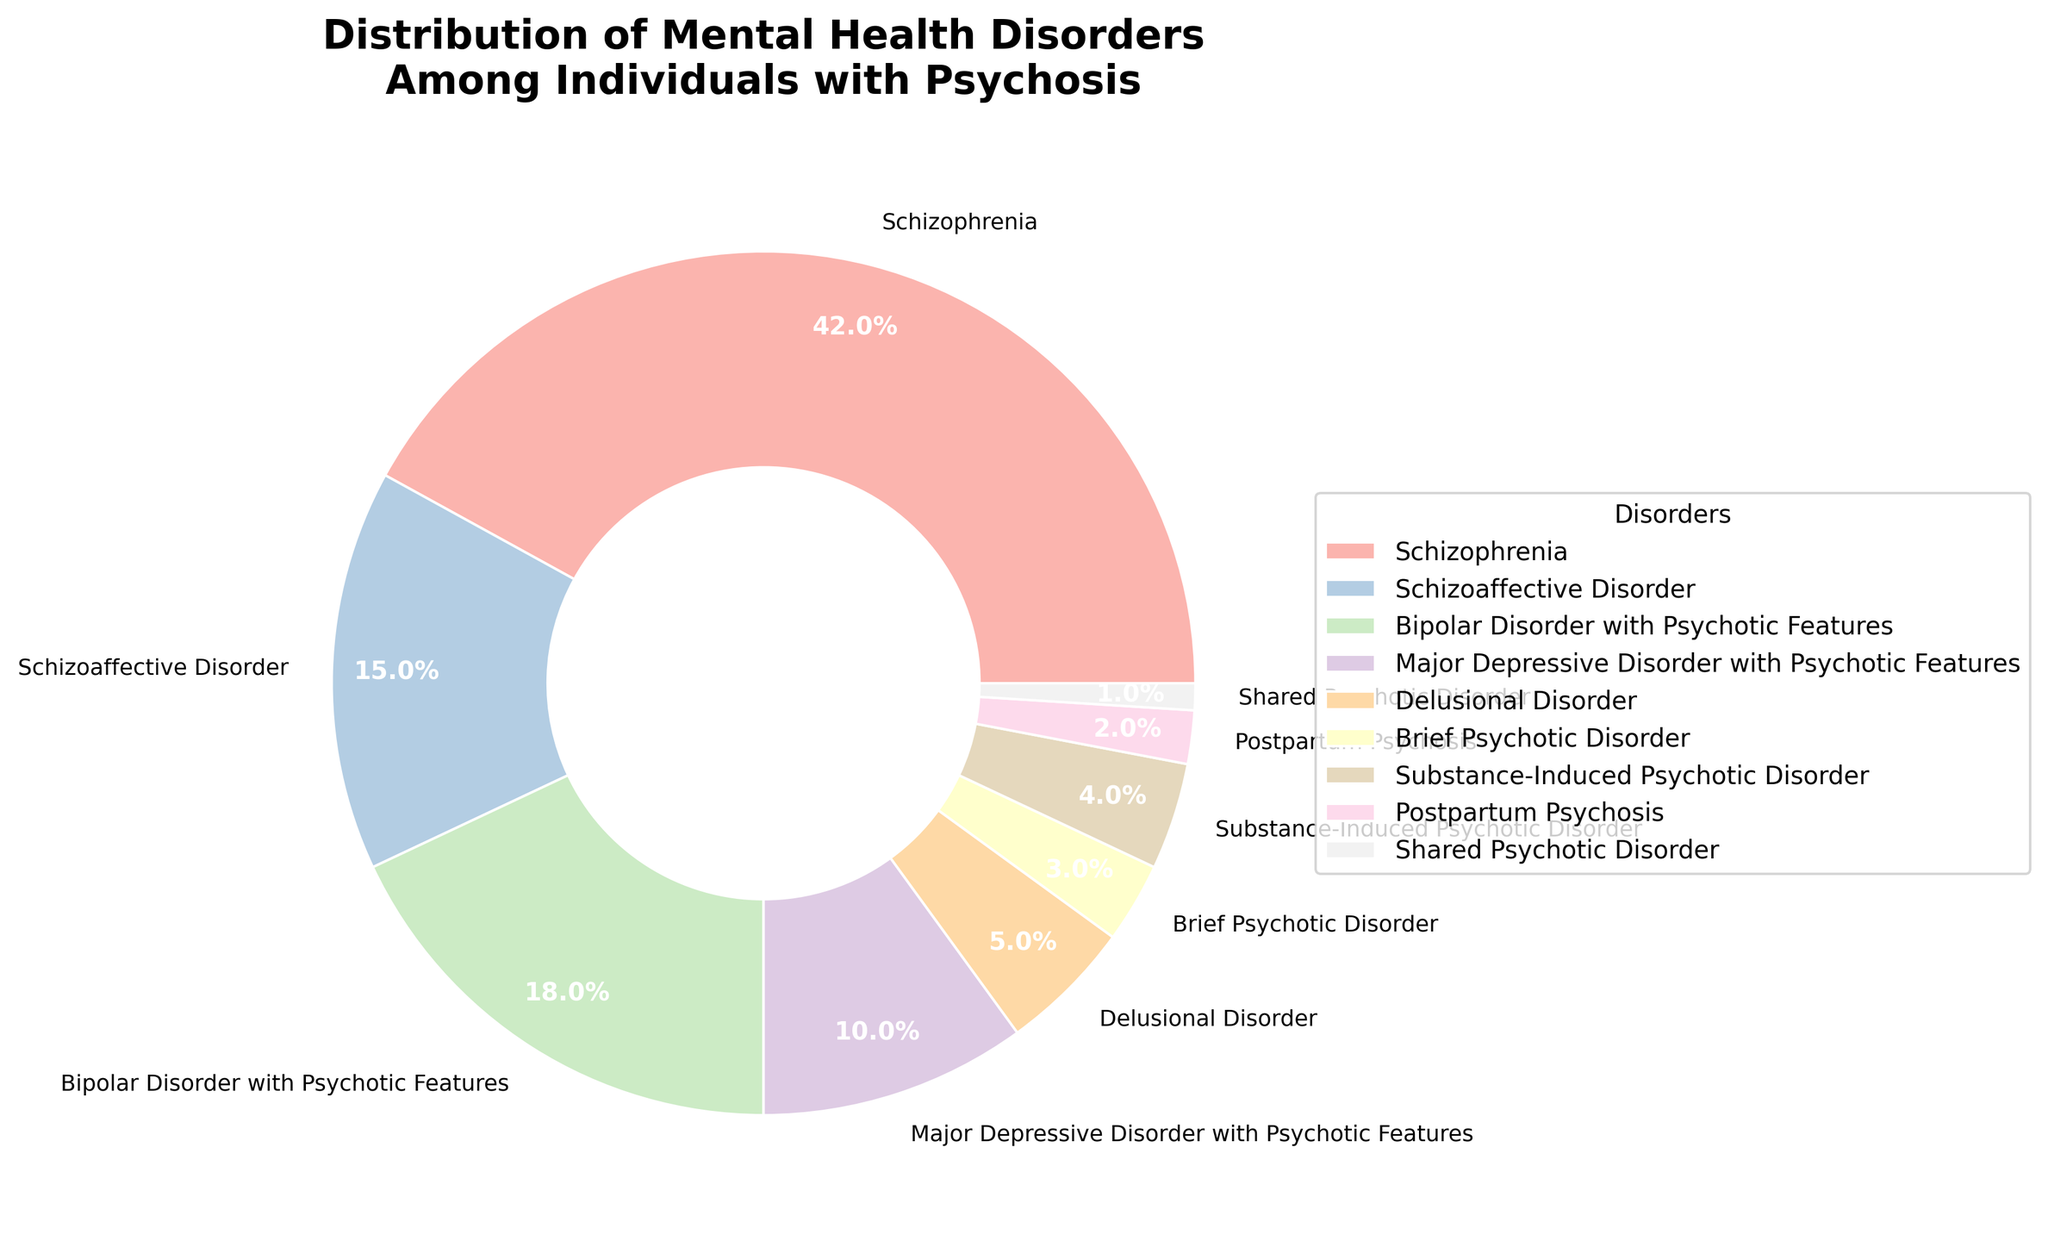What is the most common mental health disorder among individuals with psychosis as shown in the pie chart? The pie chart shows the distribution of different mental health disorders among individuals with psychosis. The largest section of the pie chart corresponds to Schizophrenia.
Answer: Schizophrenia What is the combined percentage of individuals with Schizoaffective Disorder and Major Depressive Disorder with Psychotic Features? The pie chart shows that Schizoaffective Disorder accounts for 15% and Major Depressive Disorder with Psychotic Features accounts for 10%. Adding these percentages together gives 15% + 10% = 25%.
Answer: 25% Which disorder has a higher percentage, Bipolar Disorder with Psychotic Features or Delusional Disorder? According to the pie chart, Bipolar Disorder with Psychotic Features has a percentage of 18%, while Delusional Disorder has a percentage of 5%. Since 18% is greater than 5%, Bipolar Disorder with Psychotic Features has a higher percentage.
Answer: Bipolar Disorder with Psychotic Features Which two disorders have the smallest representation in this population, jointly totaling 3%? The pie chart indicates that Postpartum Psychosis accounts for 2% and Shared Psychotic Disorder accounts for 1%. Together, they total 2% + 1% = 3%.
Answer: Postpartum Psychosis and Shared Psychotic Disorder How much greater is the percentage of Schizophrenia compared to Substance-Induced Psychotic Disorder? The pie chart states that Schizophrenia accounts for 42%, while Substance-Induced Psychotic Disorder accounts for 4%. The difference is 42% - 4% = 38%.
Answer: 38% Which color represents Schizoaffective Disorder in the pie chart? The pie chart assigns a specific color to each disorder. Schizoaffective Disorder is shown in a pastel color tone in line with the pie chart's pastel color scheme (usually a shade that stands out from the adjacent colors).
Answer: [Color description] Rank the disorders from most common to least common based on the chart. From the largest percentage to the smallest, the disorders are Schizophrenia (42%), Bipolar Disorder with Psychotic Features (18%), Schizoaffective Disorder (15%), Major Depressive Disorder with Psychotic Features (10%), Delusional Disorder (5%), Substance-Induced Psychotic Disorder (4%), Brief Psychotic Disorder (3%), Postpartum Psychosis (2%), Shared Psychotic Disorder (1%).
Answer: Schizophrenia, Bipolar Disorder with Psychotic Features, Schizoaffective Disorder, Major Depressive Disorder with Psychotic Features, Delusional Disorder, Substance-Induced Psychotic Disorder, Brief Psychotic Disorder, Postpartum Psychosis, Shared Psychotic Disorder What is the total percentage of individuals with disorders that have a percentage below 10%? The pie chart shows the following percentages for disorders below 10%: Delusional Disorder (5%), Brief Psychotic Disorder (3%), Substance-Induced Psychotic Disorder (4%), Postpartum Psychosis (2%), and Shared Psychotic Disorder (1%). Adding these together gives 5% + 3% + 4% + 2% + 1% = 15%.
Answer: 15% 